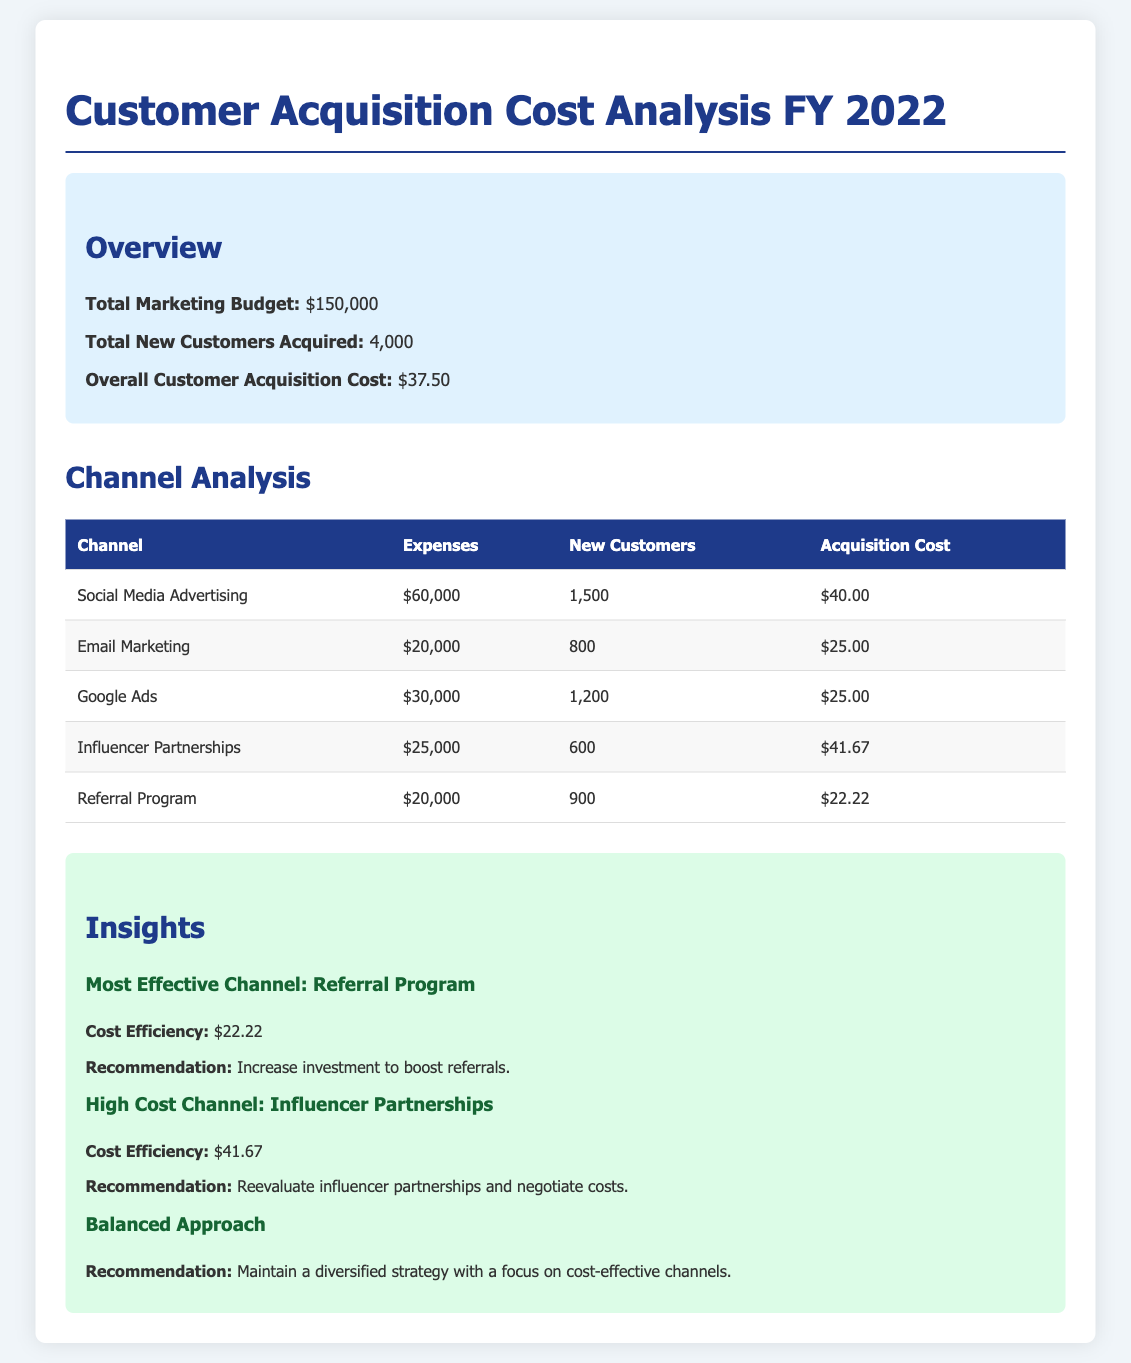What is the total marketing budget? The total marketing budget listed in the overview is $150,000.
Answer: $150,000 How many new customers were acquired? The total new customers acquired as stated in the overview is 4,000.
Answer: 4,000 What is the acquisition cost for Email Marketing? The acquisition cost specifically for Email Marketing is provided in the channel analysis as $25.00.
Answer: $25.00 Which channel has the highest expenses? The channel with the highest expenses is Social Media Advertising, which costs $60,000.
Answer: Social Media Advertising What is the cost efficiency of the Referral Program? The cost efficiency for the Referral Program is indicated as $22.22 in the insights section.
Answer: $22.22 Which marketing channel has the highest acquisition cost? The channel with the highest acquisition cost is Influencer Partnerships, costing $41.67.
Answer: Influencer Partnerships What is the overall customer acquisition cost? The overall customer acquisition cost is indicated in the overview as $37.50.
Answer: $37.50 What is the recommendation for the Referral Program? The recommendation given for the Referral Program is to increase investment to boost referrals.
Answer: Increase investment to boost referrals 